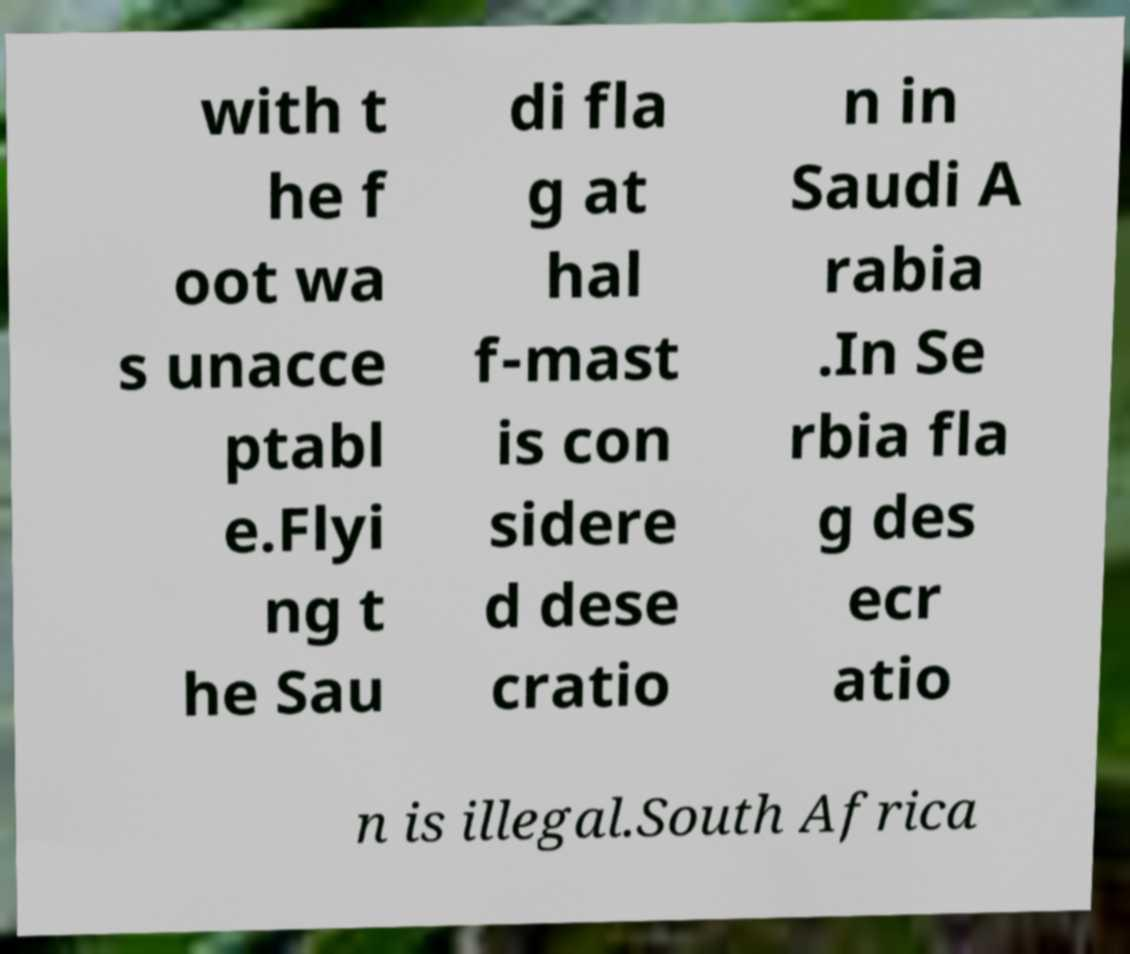Can you accurately transcribe the text from the provided image for me? with t he f oot wa s unacce ptabl e.Flyi ng t he Sau di fla g at hal f-mast is con sidere d dese cratio n in Saudi A rabia .In Se rbia fla g des ecr atio n is illegal.South Africa 